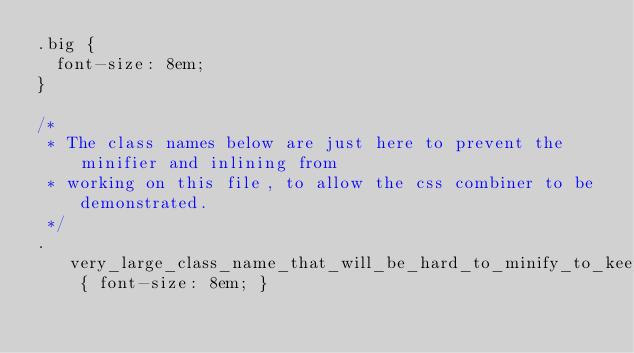Convert code to text. <code><loc_0><loc_0><loc_500><loc_500><_CSS_>.big {
  font-size: 8em;
}

/*
 * The class names below are just here to prevent the minifier and inlining from
 * working on this file, to allow the css combiner to be demonstrated.
 */
.very_large_class_name_that_will_be_hard_to_minify_to_keep_file_above_threshold_a0 { font-size: 8em; }</code> 